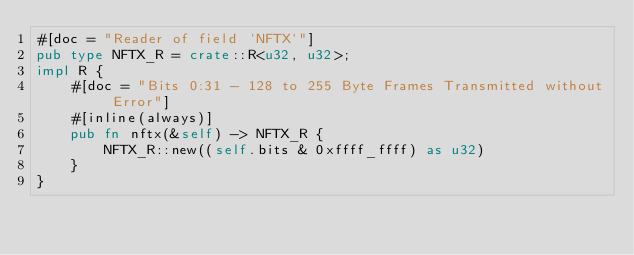Convert code to text. <code><loc_0><loc_0><loc_500><loc_500><_Rust_>#[doc = "Reader of field `NFTX`"]
pub type NFTX_R = crate::R<u32, u32>;
impl R {
    #[doc = "Bits 0:31 - 128 to 255 Byte Frames Transmitted without Error"]
    #[inline(always)]
    pub fn nftx(&self) -> NFTX_R {
        NFTX_R::new((self.bits & 0xffff_ffff) as u32)
    }
}
</code> 